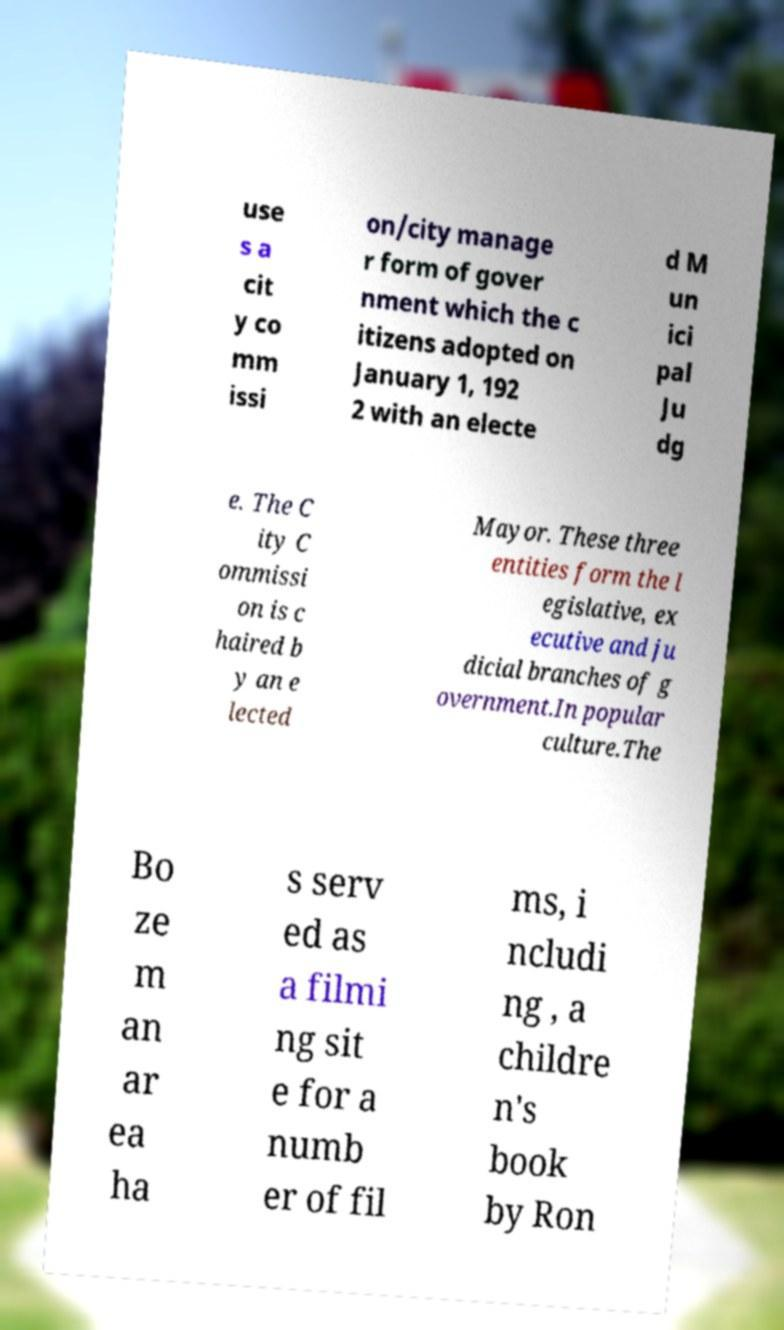For documentation purposes, I need the text within this image transcribed. Could you provide that? use s a cit y co mm issi on/city manage r form of gover nment which the c itizens adopted on January 1, 192 2 with an electe d M un ici pal Ju dg e. The C ity C ommissi on is c haired b y an e lected Mayor. These three entities form the l egislative, ex ecutive and ju dicial branches of g overnment.In popular culture.The Bo ze m an ar ea ha s serv ed as a filmi ng sit e for a numb er of fil ms, i ncludi ng , a childre n's book by Ron 